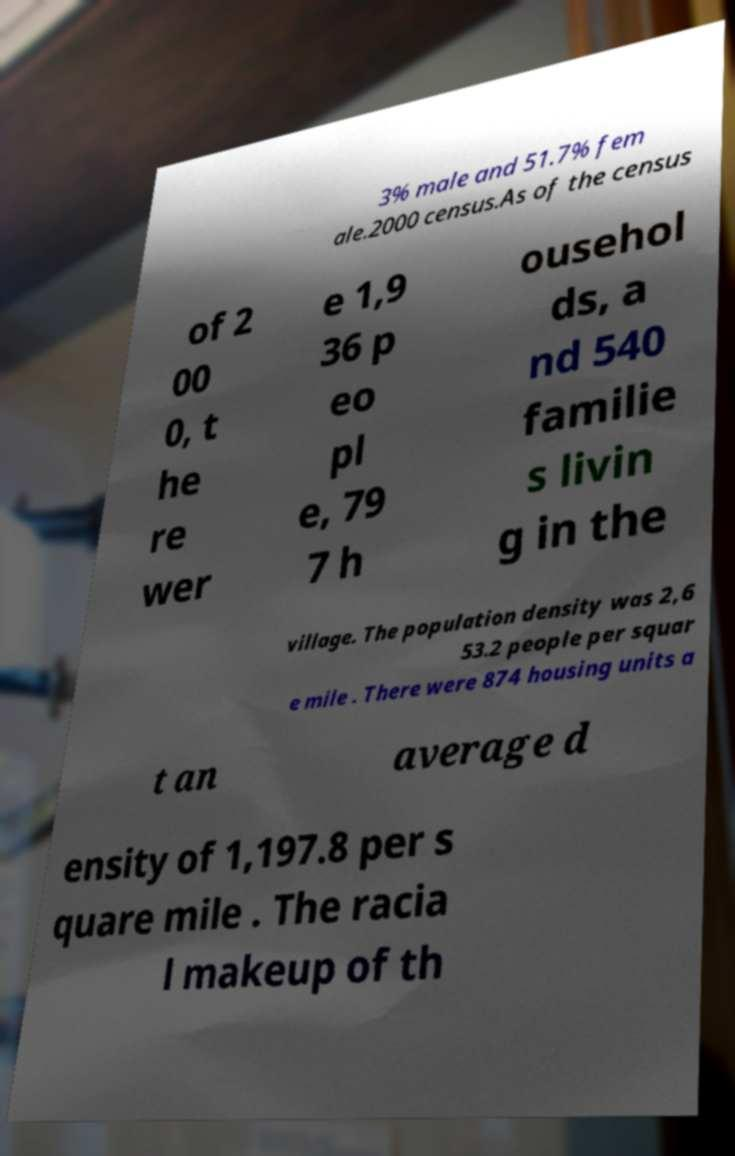Please identify and transcribe the text found in this image. 3% male and 51.7% fem ale.2000 census.As of the census of 2 00 0, t he re wer e 1,9 36 p eo pl e, 79 7 h ousehol ds, a nd 540 familie s livin g in the village. The population density was 2,6 53.2 people per squar e mile . There were 874 housing units a t an average d ensity of 1,197.8 per s quare mile . The racia l makeup of th 